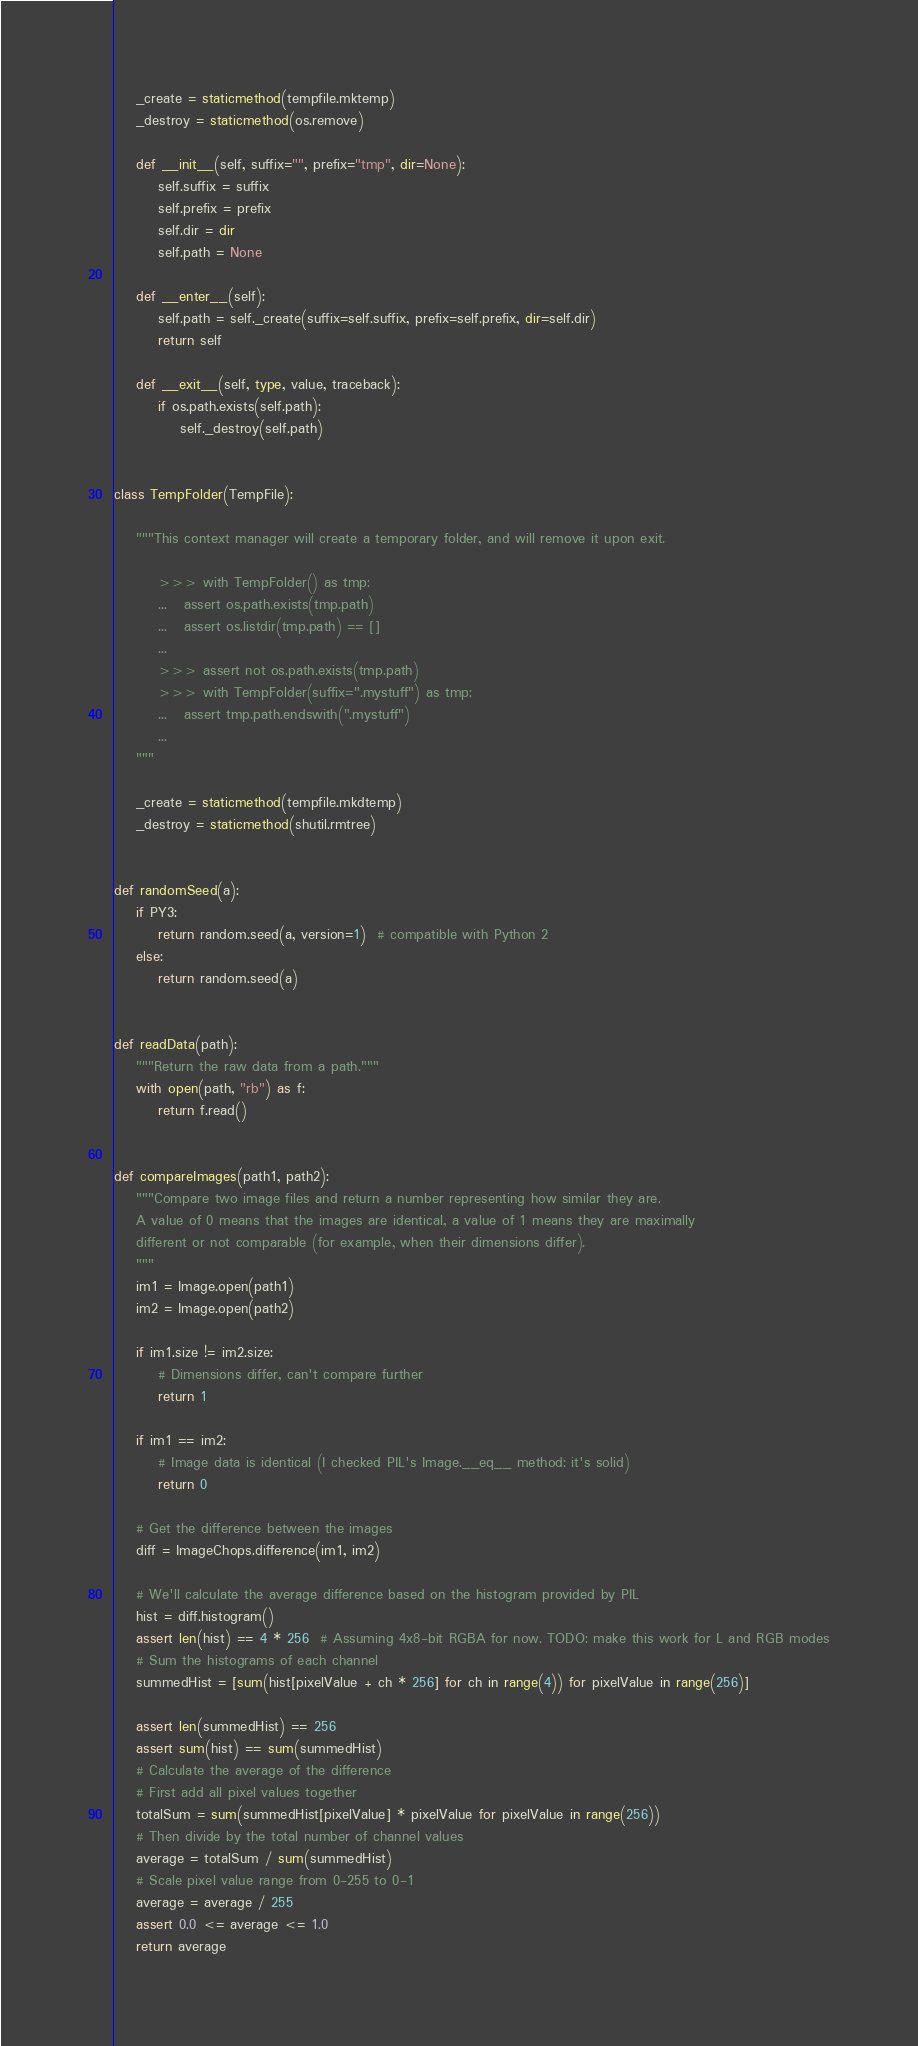Convert code to text. <code><loc_0><loc_0><loc_500><loc_500><_Python_>
    _create = staticmethod(tempfile.mktemp)
    _destroy = staticmethod(os.remove)

    def __init__(self, suffix="", prefix="tmp", dir=None):
        self.suffix = suffix
        self.prefix = prefix
        self.dir = dir
        self.path = None

    def __enter__(self):
        self.path = self._create(suffix=self.suffix, prefix=self.prefix, dir=self.dir)
        return self

    def __exit__(self, type, value, traceback):
        if os.path.exists(self.path):
            self._destroy(self.path)


class TempFolder(TempFile):

    """This context manager will create a temporary folder, and will remove it upon exit.

        >>> with TempFolder() as tmp:
        ...   assert os.path.exists(tmp.path)
        ...   assert os.listdir(tmp.path) == []
        ...
        >>> assert not os.path.exists(tmp.path)
        >>> with TempFolder(suffix=".mystuff") as tmp:
        ...   assert tmp.path.endswith(".mystuff")
        ...
    """

    _create = staticmethod(tempfile.mkdtemp)
    _destroy = staticmethod(shutil.rmtree)


def randomSeed(a):
    if PY3:
        return random.seed(a, version=1)  # compatible with Python 2
    else:
        return random.seed(a)


def readData(path):
    """Return the raw data from a path."""
    with open(path, "rb") as f:
        return f.read()


def compareImages(path1, path2):
    """Compare two image files and return a number representing how similar they are.
    A value of 0 means that the images are identical, a value of 1 means they are maximally
    different or not comparable (for example, when their dimensions differ).
    """
    im1 = Image.open(path1)
    im2 = Image.open(path2)

    if im1.size != im2.size:
        # Dimensions differ, can't compare further
        return 1

    if im1 == im2:
        # Image data is identical (I checked PIL's Image.__eq__ method: it's solid)
        return 0

    # Get the difference between the images
    diff = ImageChops.difference(im1, im2)

    # We'll calculate the average difference based on the histogram provided by PIL
    hist = diff.histogram()
    assert len(hist) == 4 * 256  # Assuming 4x8-bit RGBA for now. TODO: make this work for L and RGB modes
    # Sum the histograms of each channel
    summedHist = [sum(hist[pixelValue + ch * 256] for ch in range(4)) for pixelValue in range(256)]

    assert len(summedHist) == 256
    assert sum(hist) == sum(summedHist)
    # Calculate the average of the difference
    # First add all pixel values together
    totalSum = sum(summedHist[pixelValue] * pixelValue for pixelValue in range(256))
    # Then divide by the total number of channel values
    average = totalSum / sum(summedHist)
    # Scale pixel value range from 0-255 to 0-1
    average = average / 255
    assert 0.0 <= average <= 1.0
    return average
</code> 